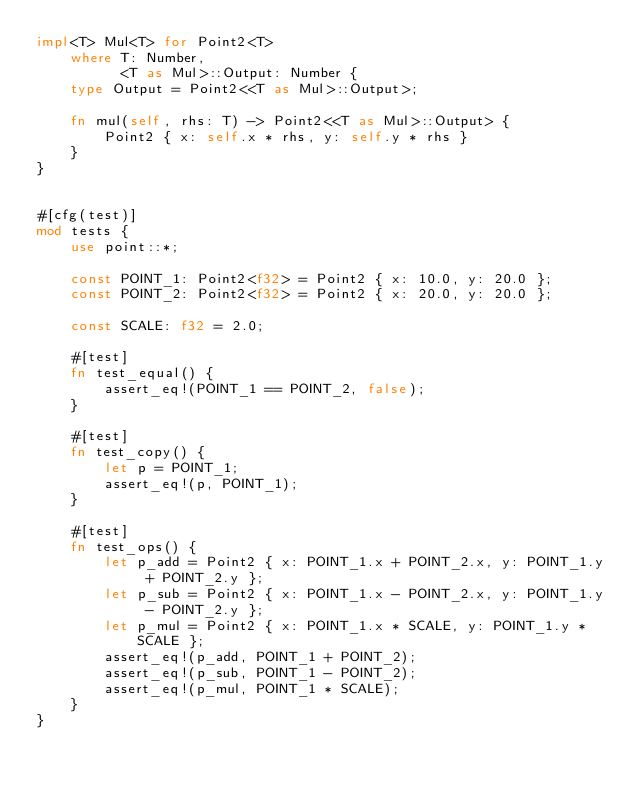Convert code to text. <code><loc_0><loc_0><loc_500><loc_500><_Rust_>impl<T> Mul<T> for Point2<T>
    where T: Number,
          <T as Mul>::Output: Number {
    type Output = Point2<<T as Mul>::Output>;

    fn mul(self, rhs: T) -> Point2<<T as Mul>::Output> {
        Point2 { x: self.x * rhs, y: self.y * rhs }
    }
}


#[cfg(test)]
mod tests {
    use point::*;

    const POINT_1: Point2<f32> = Point2 { x: 10.0, y: 20.0 };
    const POINT_2: Point2<f32> = Point2 { x: 20.0, y: 20.0 };

    const SCALE: f32 = 2.0;

    #[test]
    fn test_equal() {
        assert_eq!(POINT_1 == POINT_2, false);
    }

    #[test]
    fn test_copy() {
        let p = POINT_1;
        assert_eq!(p, POINT_1);
    }

    #[test]
    fn test_ops() {
        let p_add = Point2 { x: POINT_1.x + POINT_2.x, y: POINT_1.y + POINT_2.y };
        let p_sub = Point2 { x: POINT_1.x - POINT_2.x, y: POINT_1.y - POINT_2.y };
        let p_mul = Point2 { x: POINT_1.x * SCALE, y: POINT_1.y * SCALE };
        assert_eq!(p_add, POINT_1 + POINT_2);
        assert_eq!(p_sub, POINT_1 - POINT_2);
        assert_eq!(p_mul, POINT_1 * SCALE);
    }
}
</code> 